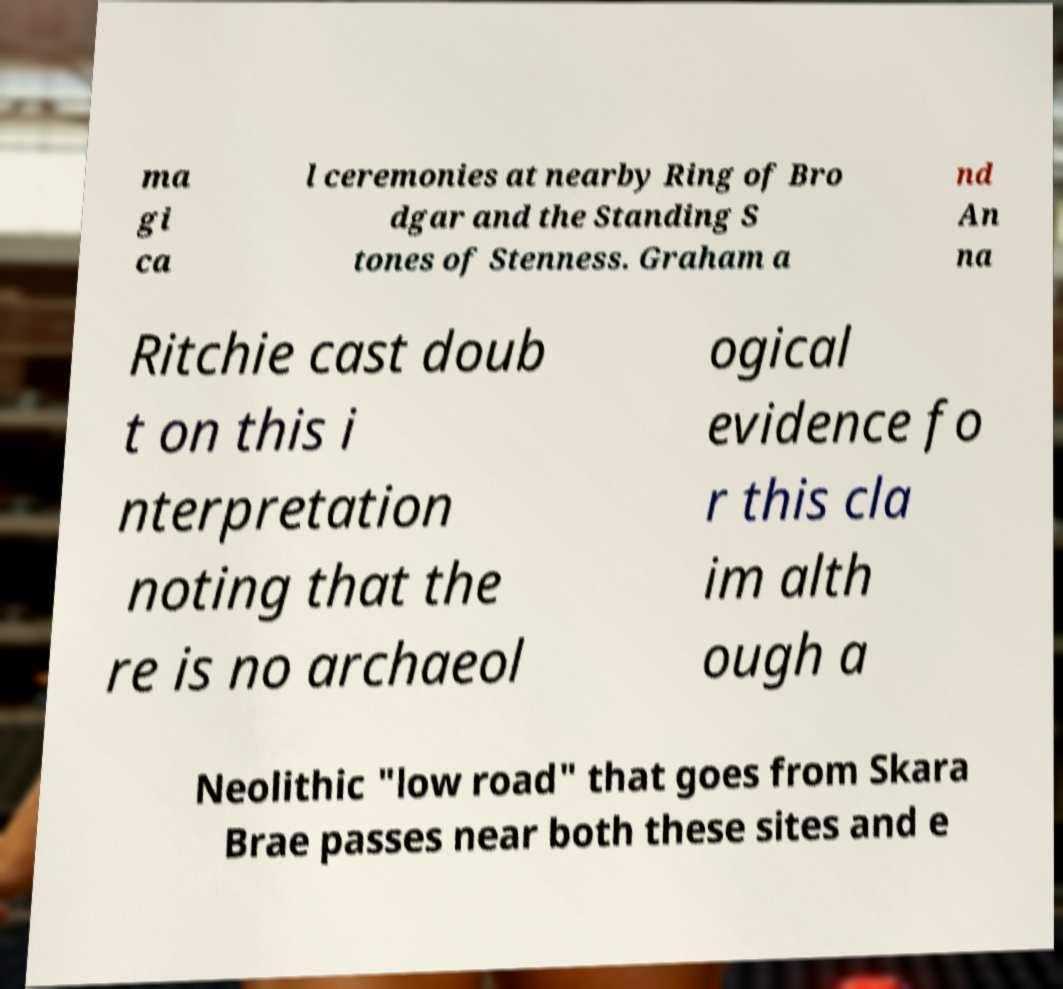Please read and relay the text visible in this image. What does it say? ma gi ca l ceremonies at nearby Ring of Bro dgar and the Standing S tones of Stenness. Graham a nd An na Ritchie cast doub t on this i nterpretation noting that the re is no archaeol ogical evidence fo r this cla im alth ough a Neolithic "low road" that goes from Skara Brae passes near both these sites and e 